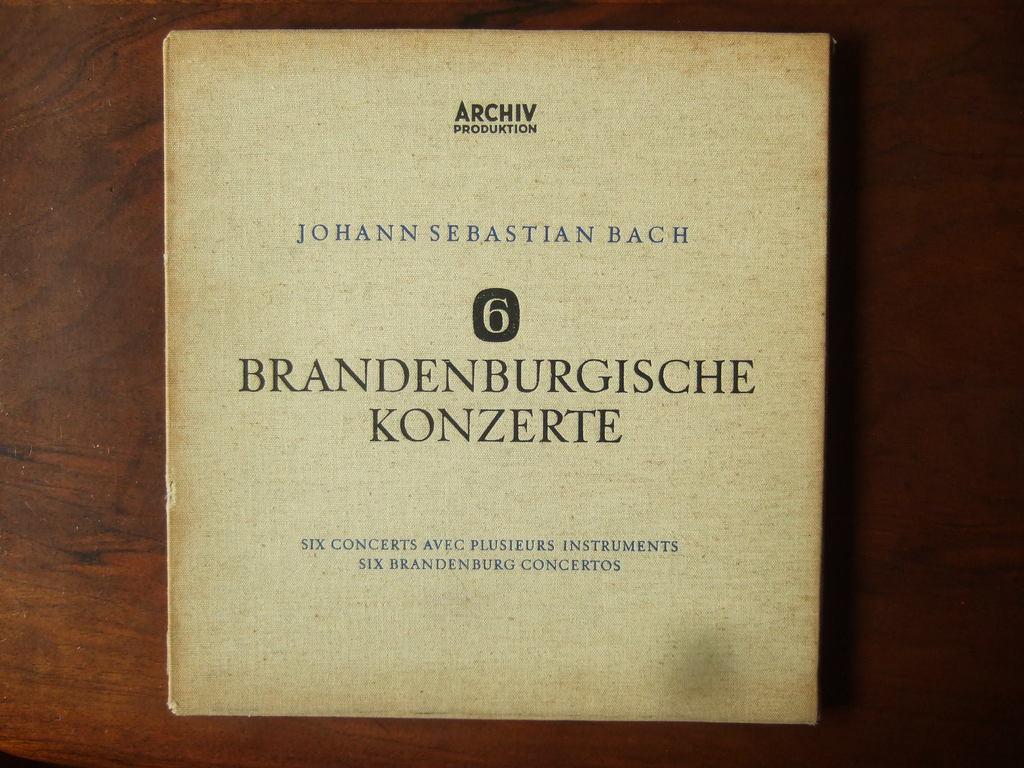How many concerts are in this piece of music?
Give a very brief answer. 6. 